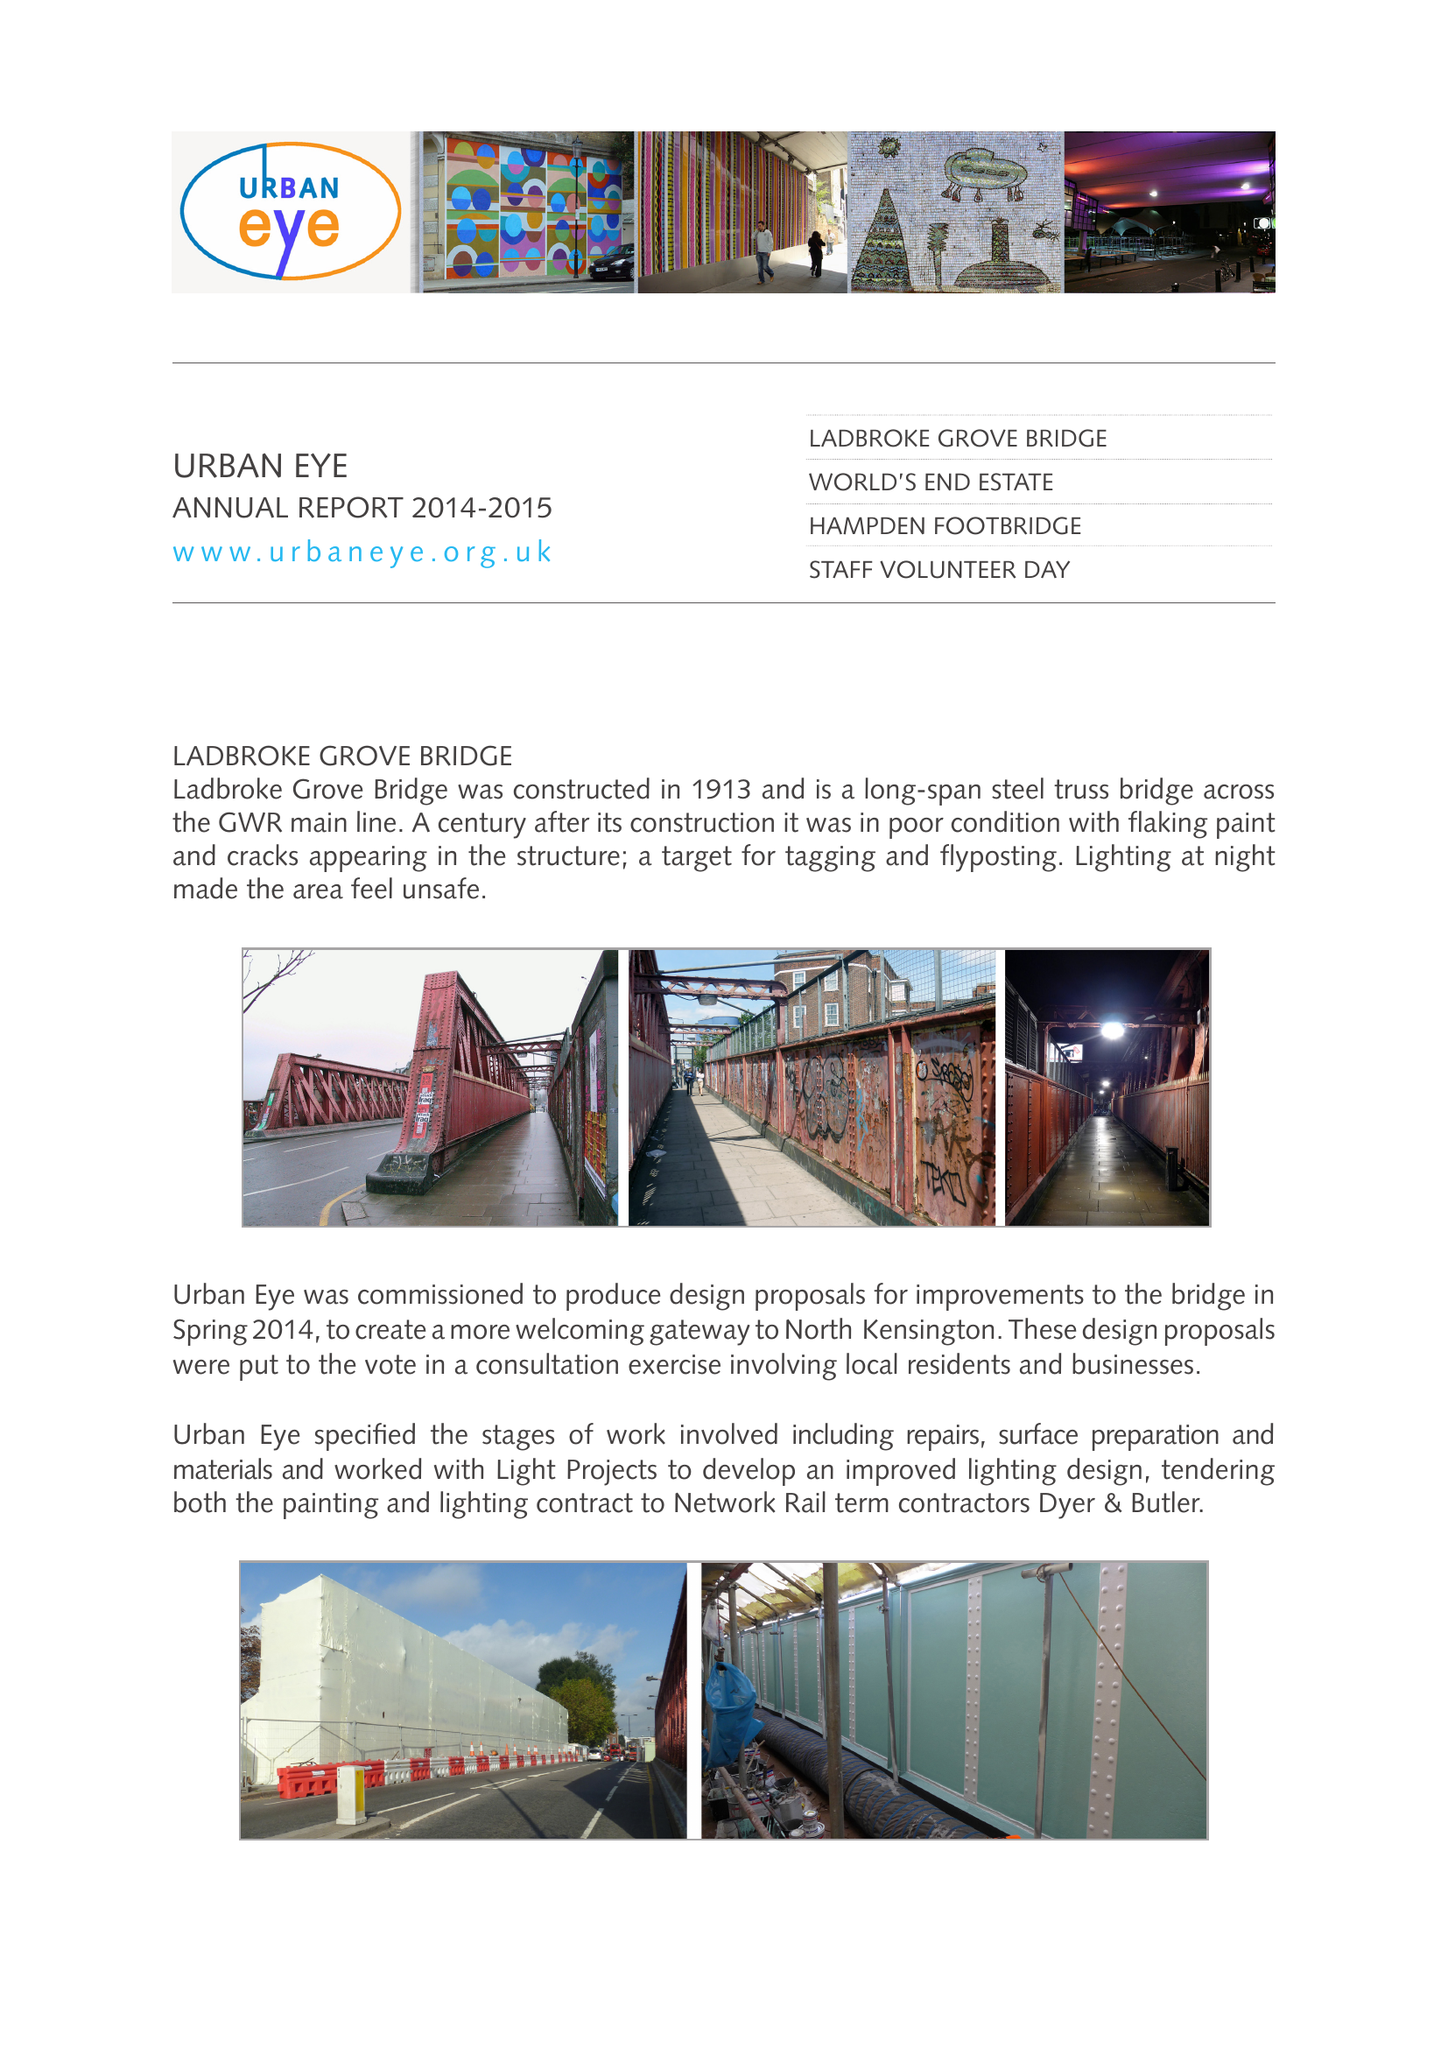What is the value for the report_date?
Answer the question using a single word or phrase. 2015-03-31 